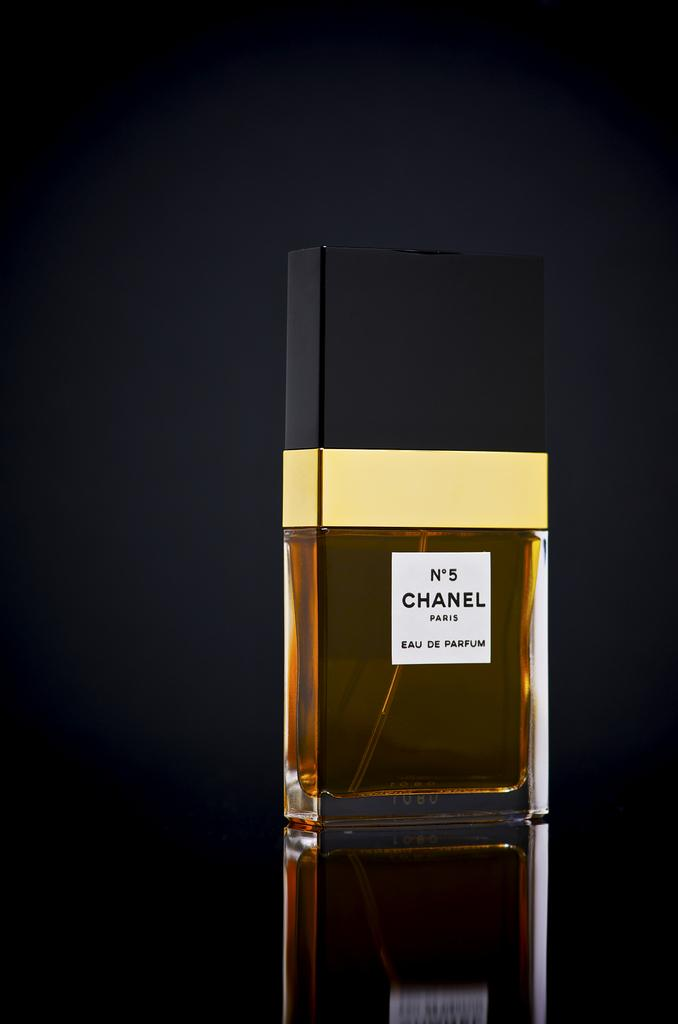<image>
Present a compact description of the photo's key features. A brand new bottle of Chanel No. 5 perfume on a reflective surface. 